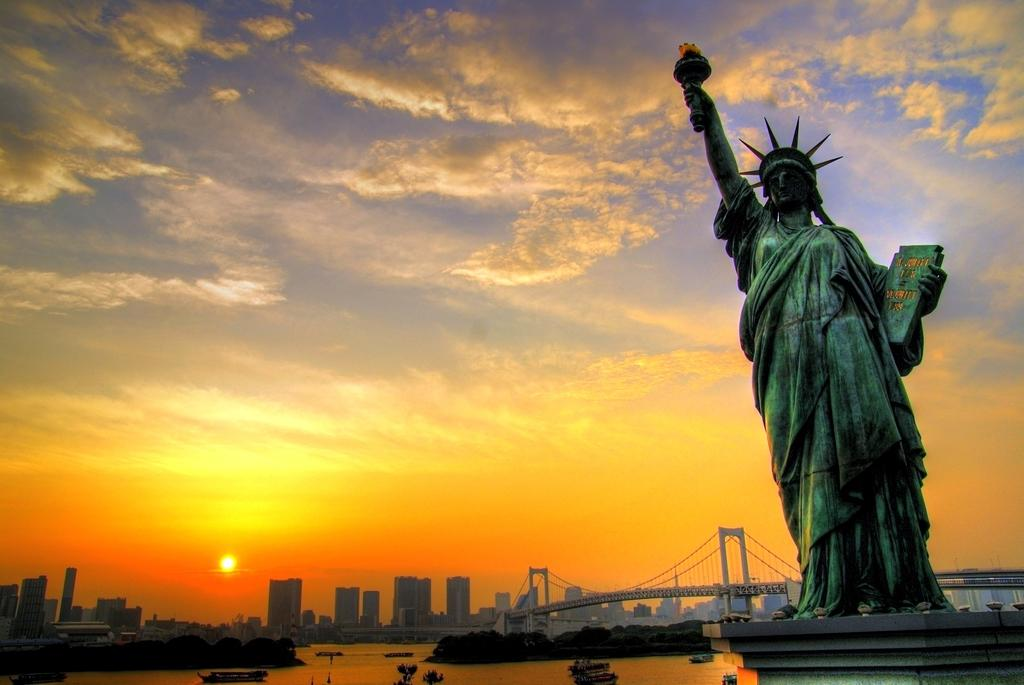What is the main subject of the image? There is a statue in the image. What can be seen in the background of the image? There is water, trees, a bridge, and buildings visible in the background of the image. What is the condition of the sky in the image? The sky is visible in the image, with colors including yellow, orange, blue, and white. The sun is observable in the sky. What type of pin is the statue holding in the image? There is no pin present in the image; the statue is not holding anything. How does the wind affect the statue in the image? The image does not show any wind or its effects on the statue. 